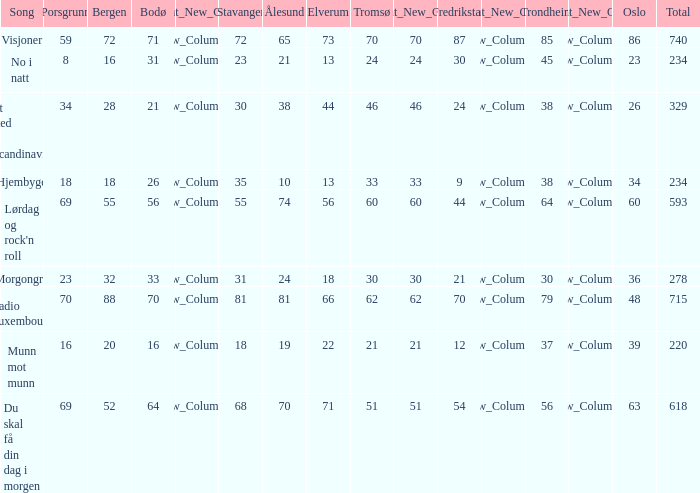When the complete score reaches 740, what is tromso? 70.0. 